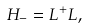Convert formula to latex. <formula><loc_0><loc_0><loc_500><loc_500>H _ { - } = L ^ { + } L ,</formula> 